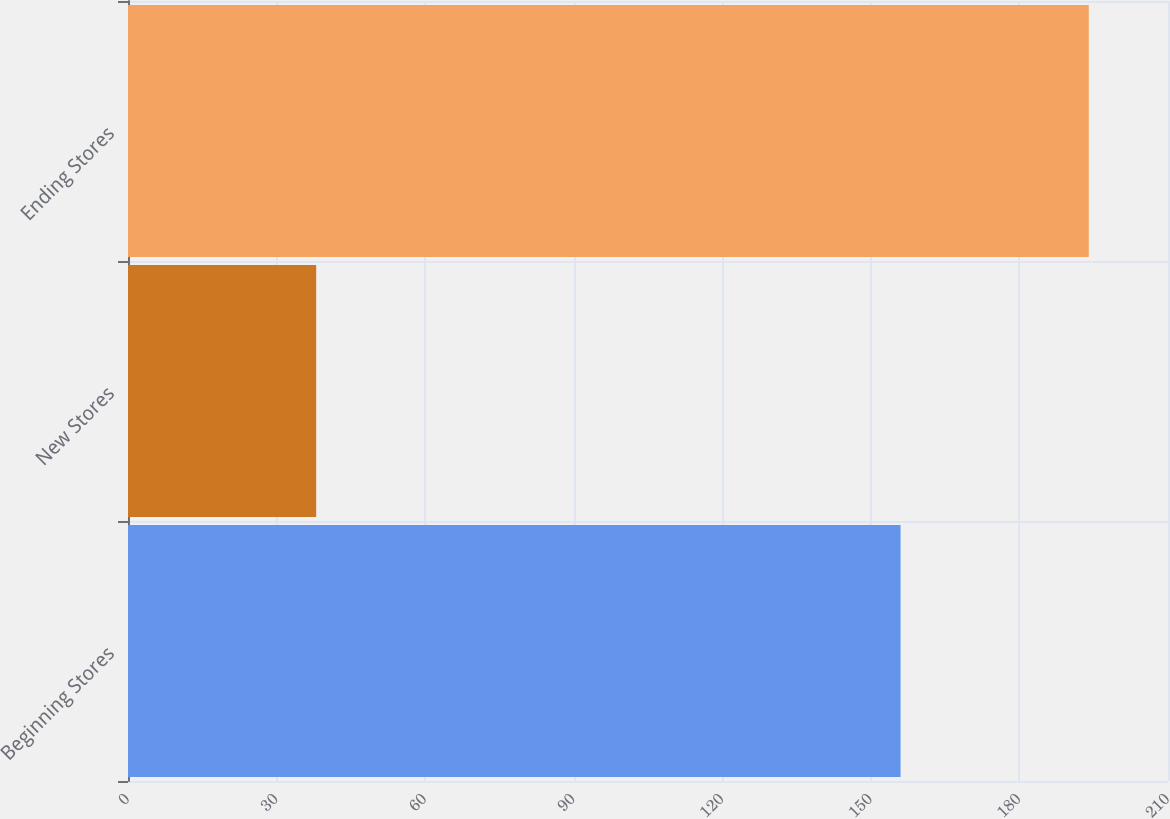Convert chart to OTSL. <chart><loc_0><loc_0><loc_500><loc_500><bar_chart><fcel>Beginning Stores<fcel>New Stores<fcel>Ending Stores<nl><fcel>156<fcel>38<fcel>194<nl></chart> 